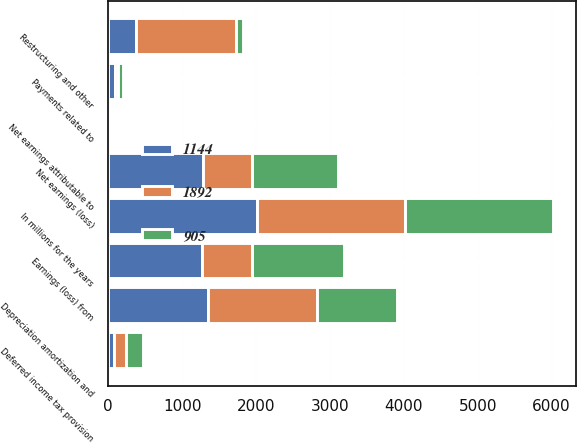Convert chart to OTSL. <chart><loc_0><loc_0><loc_500><loc_500><stacked_bar_chart><ecel><fcel>In millions for the years<fcel>Net earnings (loss)<fcel>Net earnings attributable to<fcel>Earnings (loss) from<fcel>Depreciation amortization and<fcel>Deferred income tax provision<fcel>Restructuring and other<fcel>Payments related to<nl><fcel>1892<fcel>2009<fcel>663<fcel>18<fcel>681<fcel>1472<fcel>160<fcel>1353<fcel>38<nl><fcel>1144<fcel>2008<fcel>1282<fcel>3<fcel>1266<fcel>1347<fcel>81<fcel>370<fcel>87<nl><fcel>905<fcel>2007<fcel>1168<fcel>24<fcel>1239<fcel>1086<fcel>232<fcel>95<fcel>78<nl></chart> 